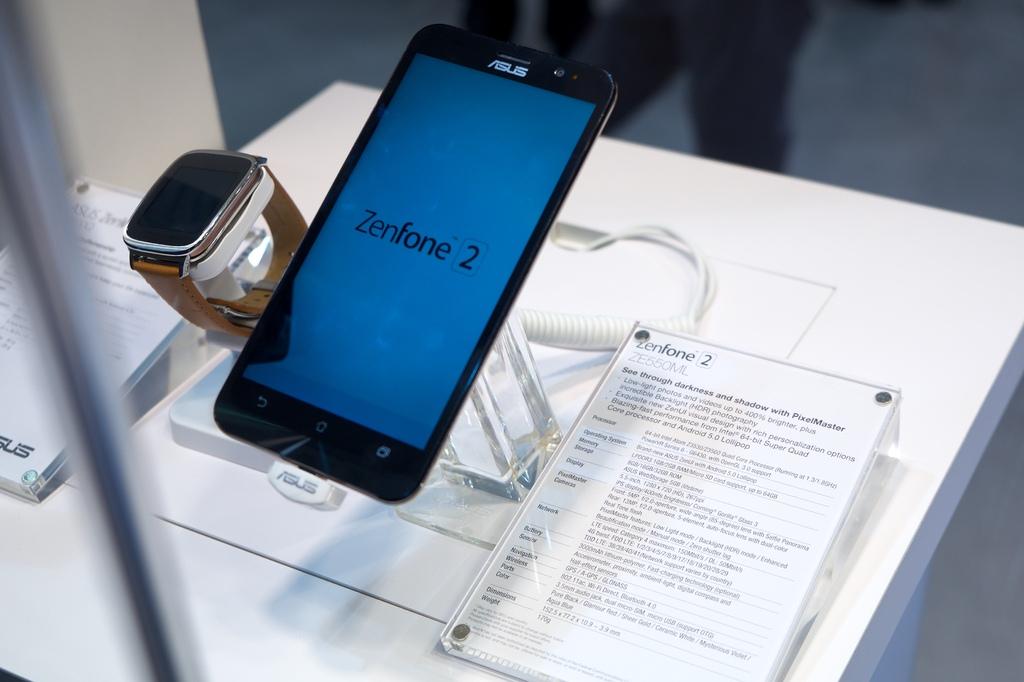What is the phone manufacturer shown?
Your answer should be compact. Asus. What is the version of this phone?
Give a very brief answer. Zenfone 2. 